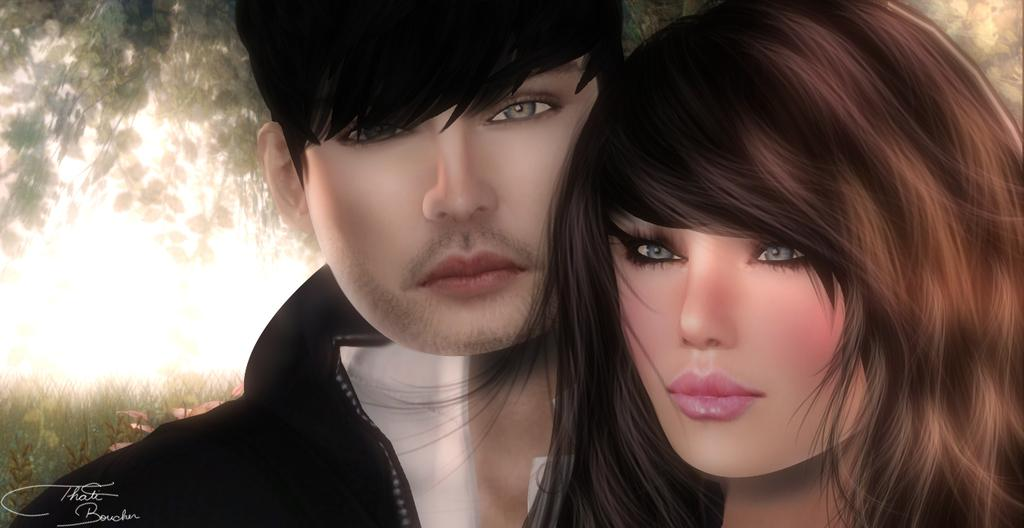Who is present in the image? There is a couple in the image. What can be seen in the background of the image? There are trees in the background of the image. What type of shelf can be seen in the image? There is no shelf present in the image. What do the couple believe in the image? The image does not provide any information about the couple's beliefs. 